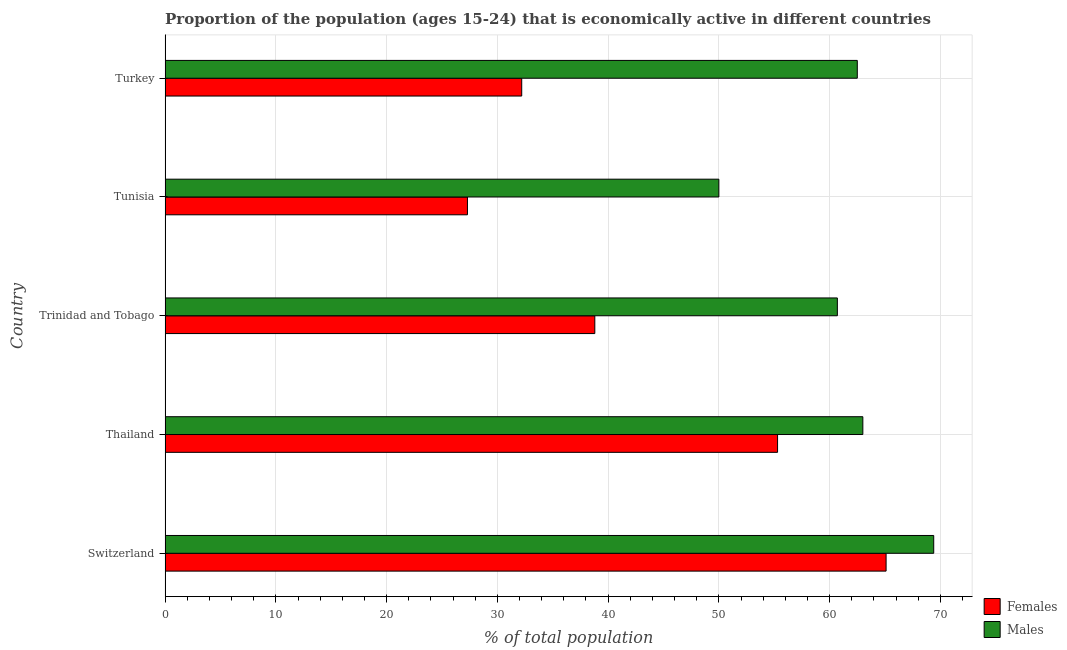How many different coloured bars are there?
Your answer should be very brief. 2. What is the label of the 3rd group of bars from the top?
Your answer should be compact. Trinidad and Tobago. What is the percentage of economically active female population in Switzerland?
Provide a succinct answer. 65.1. Across all countries, what is the maximum percentage of economically active female population?
Your answer should be very brief. 65.1. In which country was the percentage of economically active female population maximum?
Keep it short and to the point. Switzerland. In which country was the percentage of economically active female population minimum?
Give a very brief answer. Tunisia. What is the total percentage of economically active male population in the graph?
Ensure brevity in your answer.  305.6. What is the difference between the percentage of economically active male population in Switzerland and that in Turkey?
Give a very brief answer. 6.9. What is the difference between the percentage of economically active male population in Turkey and the percentage of economically active female population in Thailand?
Offer a very short reply. 7.2. What is the average percentage of economically active female population per country?
Your answer should be very brief. 43.74. What is the difference between the percentage of economically active female population and percentage of economically active male population in Switzerland?
Offer a very short reply. -4.3. In how many countries, is the percentage of economically active female population greater than 50 %?
Offer a terse response. 2. What is the ratio of the percentage of economically active female population in Trinidad and Tobago to that in Tunisia?
Keep it short and to the point. 1.42. What is the difference between the highest and the second highest percentage of economically active male population?
Ensure brevity in your answer.  6.4. What is the difference between the highest and the lowest percentage of economically active female population?
Offer a very short reply. 37.8. In how many countries, is the percentage of economically active male population greater than the average percentage of economically active male population taken over all countries?
Provide a short and direct response. 3. Is the sum of the percentage of economically active male population in Thailand and Tunisia greater than the maximum percentage of economically active female population across all countries?
Keep it short and to the point. Yes. What does the 1st bar from the top in Switzerland represents?
Keep it short and to the point. Males. What does the 1st bar from the bottom in Trinidad and Tobago represents?
Your answer should be very brief. Females. Are all the bars in the graph horizontal?
Provide a short and direct response. Yes. How many countries are there in the graph?
Your response must be concise. 5. What is the difference between two consecutive major ticks on the X-axis?
Give a very brief answer. 10. Does the graph contain grids?
Make the answer very short. Yes. Where does the legend appear in the graph?
Give a very brief answer. Bottom right. What is the title of the graph?
Your response must be concise. Proportion of the population (ages 15-24) that is economically active in different countries. What is the label or title of the X-axis?
Offer a terse response. % of total population. What is the label or title of the Y-axis?
Give a very brief answer. Country. What is the % of total population of Females in Switzerland?
Your answer should be very brief. 65.1. What is the % of total population of Males in Switzerland?
Give a very brief answer. 69.4. What is the % of total population of Females in Thailand?
Make the answer very short. 55.3. What is the % of total population of Males in Thailand?
Give a very brief answer. 63. What is the % of total population in Females in Trinidad and Tobago?
Give a very brief answer. 38.8. What is the % of total population in Males in Trinidad and Tobago?
Ensure brevity in your answer.  60.7. What is the % of total population in Females in Tunisia?
Keep it short and to the point. 27.3. What is the % of total population in Females in Turkey?
Provide a short and direct response. 32.2. What is the % of total population in Males in Turkey?
Offer a very short reply. 62.5. Across all countries, what is the maximum % of total population in Females?
Offer a terse response. 65.1. Across all countries, what is the maximum % of total population in Males?
Make the answer very short. 69.4. Across all countries, what is the minimum % of total population of Females?
Provide a short and direct response. 27.3. What is the total % of total population in Females in the graph?
Your response must be concise. 218.7. What is the total % of total population of Males in the graph?
Offer a very short reply. 305.6. What is the difference between the % of total population in Females in Switzerland and that in Thailand?
Provide a short and direct response. 9.8. What is the difference between the % of total population of Males in Switzerland and that in Thailand?
Provide a short and direct response. 6.4. What is the difference between the % of total population in Females in Switzerland and that in Trinidad and Tobago?
Your answer should be compact. 26.3. What is the difference between the % of total population of Males in Switzerland and that in Trinidad and Tobago?
Offer a terse response. 8.7. What is the difference between the % of total population in Females in Switzerland and that in Tunisia?
Give a very brief answer. 37.8. What is the difference between the % of total population of Males in Switzerland and that in Tunisia?
Provide a succinct answer. 19.4. What is the difference between the % of total population in Females in Switzerland and that in Turkey?
Offer a very short reply. 32.9. What is the difference between the % of total population in Males in Switzerland and that in Turkey?
Give a very brief answer. 6.9. What is the difference between the % of total population in Females in Thailand and that in Trinidad and Tobago?
Offer a terse response. 16.5. What is the difference between the % of total population of Males in Thailand and that in Trinidad and Tobago?
Your answer should be very brief. 2.3. What is the difference between the % of total population of Females in Thailand and that in Tunisia?
Provide a succinct answer. 28. What is the difference between the % of total population of Females in Thailand and that in Turkey?
Your answer should be very brief. 23.1. What is the difference between the % of total population in Males in Thailand and that in Turkey?
Ensure brevity in your answer.  0.5. What is the difference between the % of total population in Males in Trinidad and Tobago and that in Tunisia?
Provide a succinct answer. 10.7. What is the difference between the % of total population in Females in Trinidad and Tobago and that in Turkey?
Give a very brief answer. 6.6. What is the difference between the % of total population in Males in Tunisia and that in Turkey?
Provide a succinct answer. -12.5. What is the difference between the % of total population of Females in Switzerland and the % of total population of Males in Trinidad and Tobago?
Ensure brevity in your answer.  4.4. What is the difference between the % of total population in Females in Switzerland and the % of total population in Males in Tunisia?
Your answer should be compact. 15.1. What is the difference between the % of total population of Females in Thailand and the % of total population of Males in Turkey?
Offer a terse response. -7.2. What is the difference between the % of total population in Females in Trinidad and Tobago and the % of total population in Males in Turkey?
Make the answer very short. -23.7. What is the difference between the % of total population in Females in Tunisia and the % of total population in Males in Turkey?
Offer a very short reply. -35.2. What is the average % of total population in Females per country?
Your answer should be very brief. 43.74. What is the average % of total population in Males per country?
Ensure brevity in your answer.  61.12. What is the difference between the % of total population of Females and % of total population of Males in Thailand?
Offer a terse response. -7.7. What is the difference between the % of total population of Females and % of total population of Males in Trinidad and Tobago?
Offer a terse response. -21.9. What is the difference between the % of total population in Females and % of total population in Males in Tunisia?
Your response must be concise. -22.7. What is the difference between the % of total population in Females and % of total population in Males in Turkey?
Offer a very short reply. -30.3. What is the ratio of the % of total population of Females in Switzerland to that in Thailand?
Provide a short and direct response. 1.18. What is the ratio of the % of total population of Males in Switzerland to that in Thailand?
Keep it short and to the point. 1.1. What is the ratio of the % of total population in Females in Switzerland to that in Trinidad and Tobago?
Your response must be concise. 1.68. What is the ratio of the % of total population in Males in Switzerland to that in Trinidad and Tobago?
Give a very brief answer. 1.14. What is the ratio of the % of total population of Females in Switzerland to that in Tunisia?
Your answer should be very brief. 2.38. What is the ratio of the % of total population of Males in Switzerland to that in Tunisia?
Ensure brevity in your answer.  1.39. What is the ratio of the % of total population in Females in Switzerland to that in Turkey?
Provide a succinct answer. 2.02. What is the ratio of the % of total population in Males in Switzerland to that in Turkey?
Your answer should be very brief. 1.11. What is the ratio of the % of total population of Females in Thailand to that in Trinidad and Tobago?
Ensure brevity in your answer.  1.43. What is the ratio of the % of total population in Males in Thailand to that in Trinidad and Tobago?
Make the answer very short. 1.04. What is the ratio of the % of total population in Females in Thailand to that in Tunisia?
Make the answer very short. 2.03. What is the ratio of the % of total population in Males in Thailand to that in Tunisia?
Offer a terse response. 1.26. What is the ratio of the % of total population of Females in Thailand to that in Turkey?
Your answer should be compact. 1.72. What is the ratio of the % of total population in Males in Thailand to that in Turkey?
Offer a terse response. 1.01. What is the ratio of the % of total population in Females in Trinidad and Tobago to that in Tunisia?
Make the answer very short. 1.42. What is the ratio of the % of total population in Males in Trinidad and Tobago to that in Tunisia?
Keep it short and to the point. 1.21. What is the ratio of the % of total population of Females in Trinidad and Tobago to that in Turkey?
Offer a very short reply. 1.21. What is the ratio of the % of total population of Males in Trinidad and Tobago to that in Turkey?
Your answer should be very brief. 0.97. What is the ratio of the % of total population of Females in Tunisia to that in Turkey?
Provide a succinct answer. 0.85. What is the ratio of the % of total population in Males in Tunisia to that in Turkey?
Keep it short and to the point. 0.8. What is the difference between the highest and the second highest % of total population in Females?
Your response must be concise. 9.8. What is the difference between the highest and the lowest % of total population of Females?
Give a very brief answer. 37.8. 